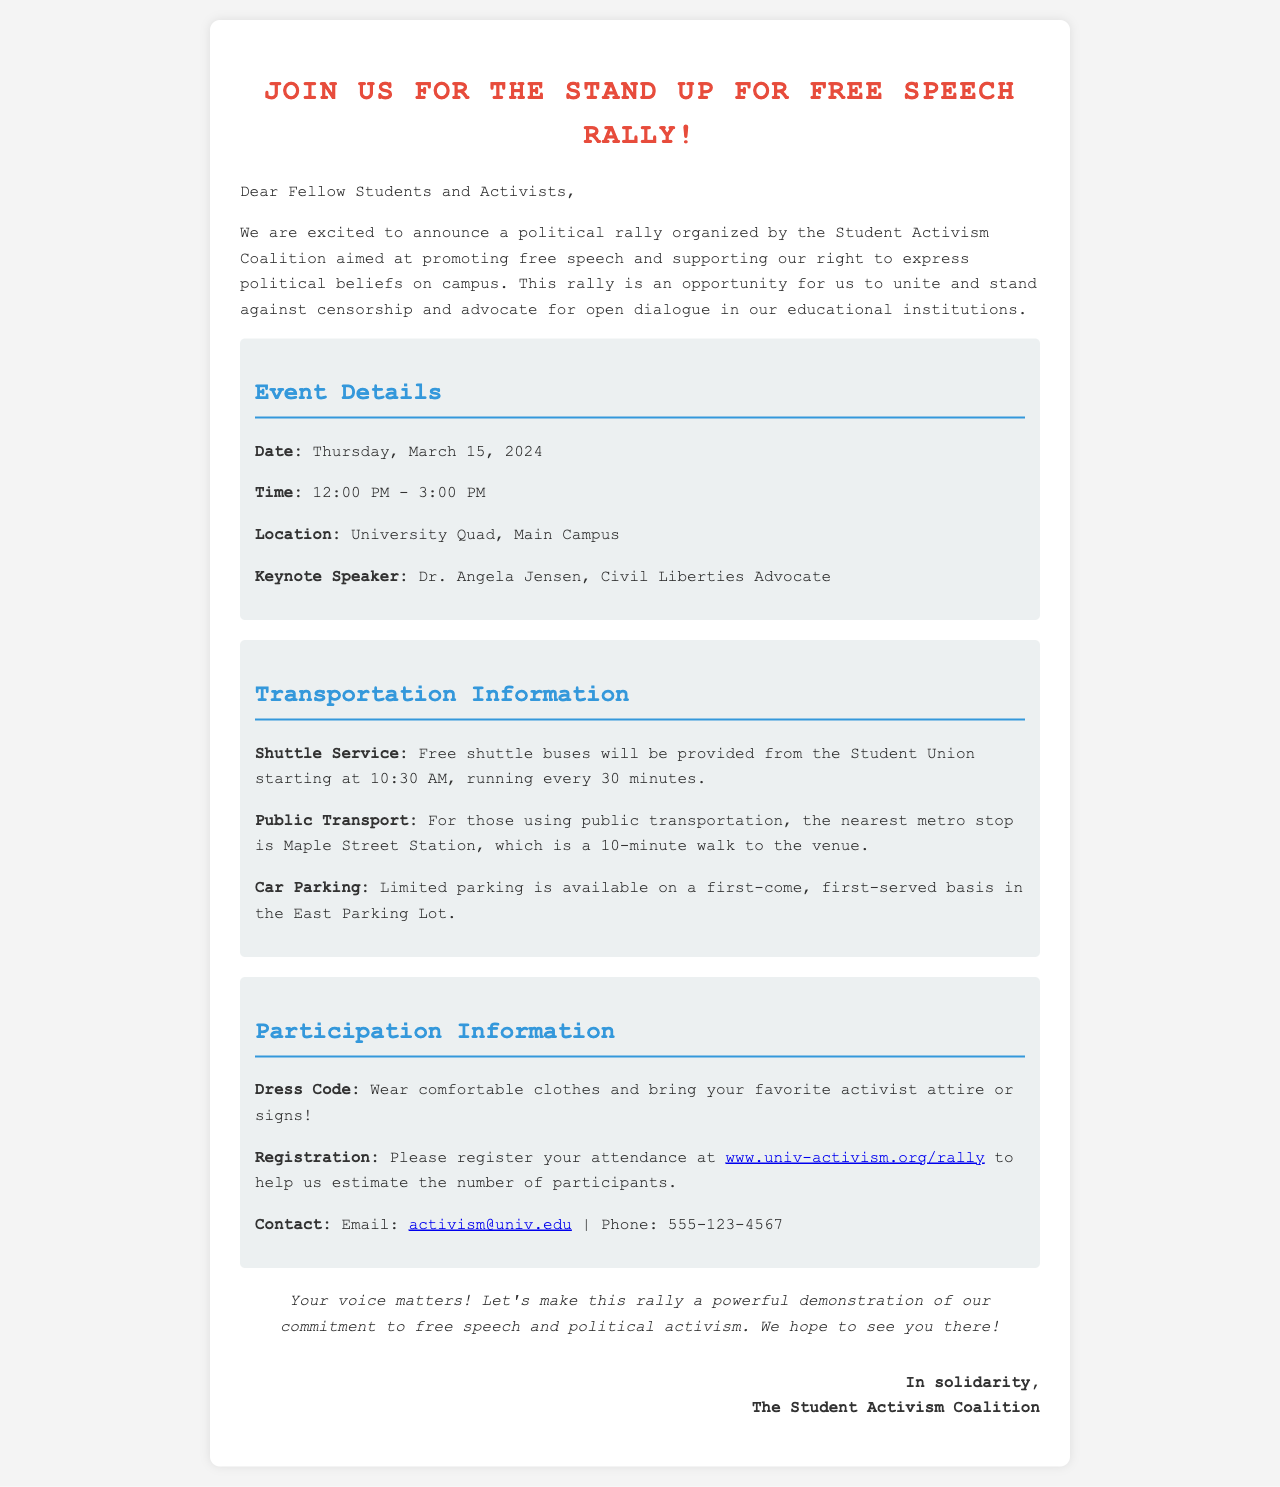What is the date of the rally? The rally is scheduled for March 15, 2024, as stated in the event details.
Answer: March 15, 2024 Who is the keynote speaker? The document mentions Dr. Angela Jensen as the keynote speaker in the event details.
Answer: Dr. Angela Jensen What time does the rally start? The rally begins at 12:00 PM, as outlined in the event details section.
Answer: 12:00 PM What type of attire should participants wear? The dress code suggests wearing comfortable clothes and activist attire or signs.
Answer: Comfortable clothes and activist attire How often will the shuttle buses run? The document states that the shuttle buses will run every 30 minutes starting at 10:30 AM.
Answer: Every 30 minutes What should participants do to register for the event? Participants are encouraged to register their attendance at the provided link to help estimate participants.
Answer: Register at www.univ-activism.org/rally What is the contact email for inquiries? The contact email for inquiries is provided in the participation information section.
Answer: activism@univ.edu Is parking available at the venue? The document notes limited parking on a first-come, first-served basis in the East Parking Lot.
Answer: Yes, limited parking available 